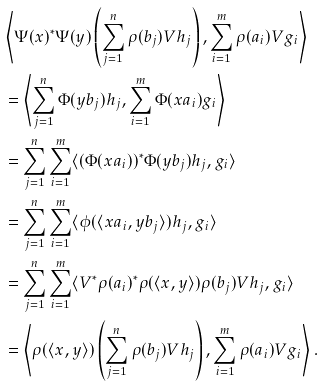Convert formula to latex. <formula><loc_0><loc_0><loc_500><loc_500>& \left \langle \Psi ( x ) ^ { * } \Psi ( y ) \left ( \sum _ { j = 1 } ^ { n } \rho ( b _ { j } ) V h _ { j } \right ) , \sum _ { i = 1 } ^ { m } \rho ( a _ { i } ) V g _ { i } \right \rangle \\ & = \left \langle \sum _ { j = 1 } ^ { n } \Phi ( y b _ { j } ) h _ { j } , \sum _ { i = 1 } ^ { m } \Phi ( x a _ { i } ) g _ { i } \right \rangle \\ & = \sum _ { j = 1 } ^ { n } \sum _ { i = 1 } ^ { m } \langle ( \Phi ( x a _ { i } ) ) ^ { * } \Phi ( y b _ { j } ) h _ { j } , g _ { i } \rangle \\ & = \sum _ { j = 1 } ^ { n } \sum _ { i = 1 } ^ { m } \langle \phi ( \langle x a _ { i } , y b _ { j } \rangle ) h _ { j } , g _ { i } \rangle \\ & = \sum _ { j = 1 } ^ { n } \sum _ { i = 1 } ^ { m } \langle V ^ { * } \rho ( a _ { i } ) ^ { * } \rho ( \langle x , y \rangle ) \rho ( b _ { j } ) V h _ { j } , g _ { i } \rangle \\ & = \left \langle \rho ( \langle x , y \rangle ) \left ( \sum _ { j = 1 } ^ { n } \rho ( b _ { j } ) V h _ { j } \right ) , \sum _ { i = 1 } ^ { m } \rho ( a _ { i } ) V g _ { i } \right \rangle .</formula> 